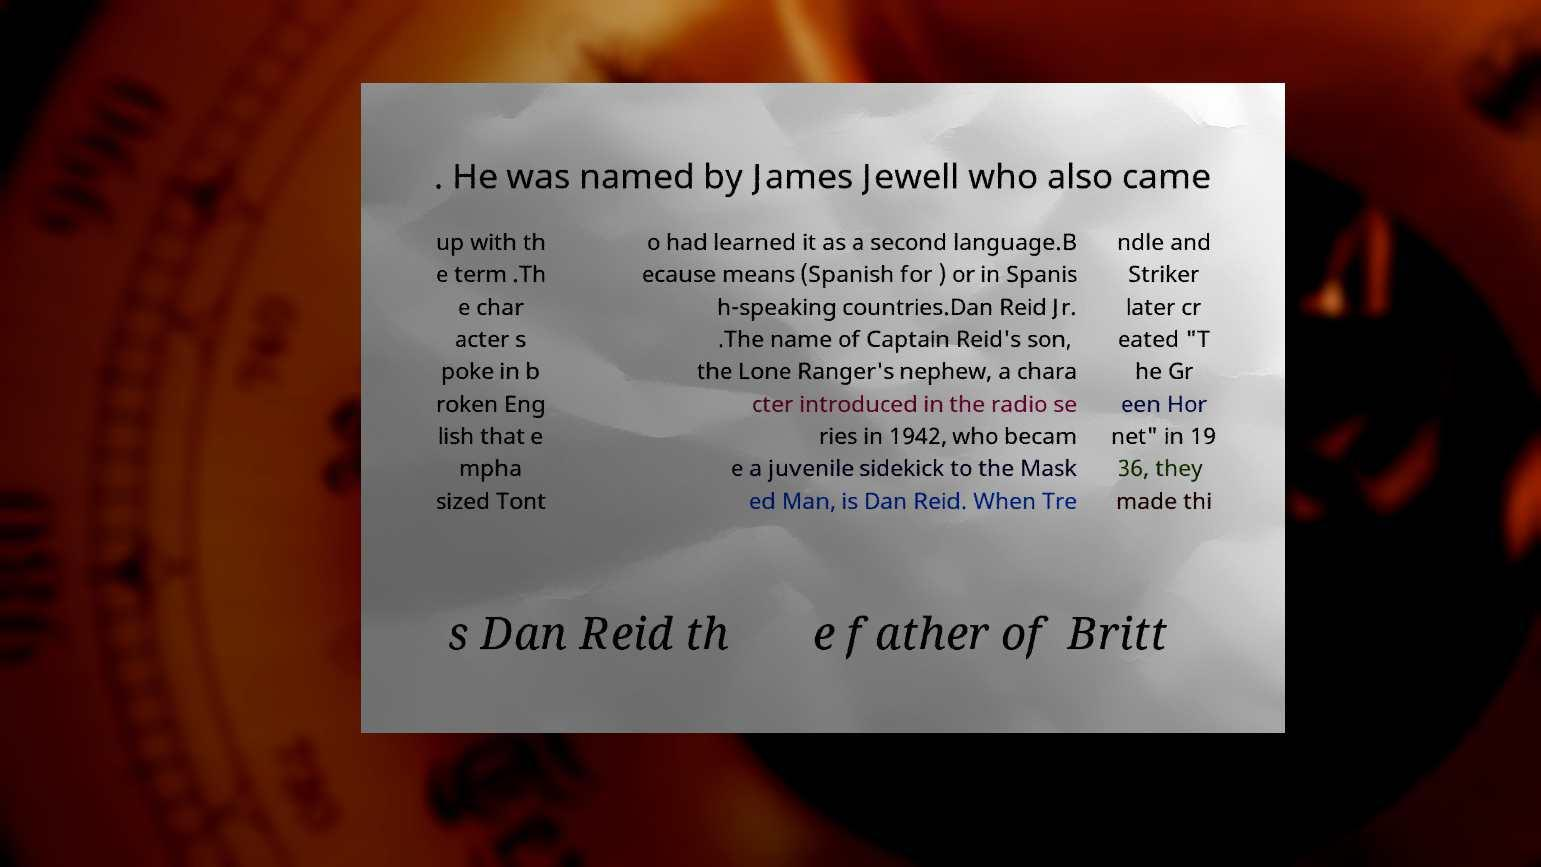I need the written content from this picture converted into text. Can you do that? . He was named by James Jewell who also came up with th e term .Th e char acter s poke in b roken Eng lish that e mpha sized Tont o had learned it as a second language.B ecause means (Spanish for ) or in Spanis h-speaking countries.Dan Reid Jr. .The name of Captain Reid's son, the Lone Ranger's nephew, a chara cter introduced in the radio se ries in 1942, who becam e a juvenile sidekick to the Mask ed Man, is Dan Reid. When Tre ndle and Striker later cr eated "T he Gr een Hor net" in 19 36, they made thi s Dan Reid th e father of Britt 